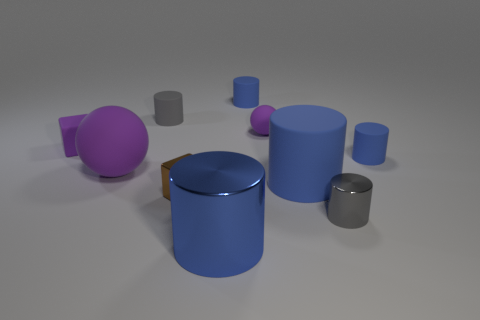Subtract all small blue rubber cylinders. How many cylinders are left? 4 Subtract all gray spheres. How many gray cylinders are left? 2 Subtract all cylinders. How many objects are left? 4 Subtract 4 cylinders. How many cylinders are left? 2 Subtract all blue cylinders. How many cylinders are left? 2 Subtract 0 yellow spheres. How many objects are left? 10 Subtract all purple cylinders. Subtract all green balls. How many cylinders are left? 6 Subtract all small blue rubber cylinders. Subtract all large metal objects. How many objects are left? 7 Add 4 purple balls. How many purple balls are left? 6 Add 8 large purple balls. How many large purple balls exist? 9 